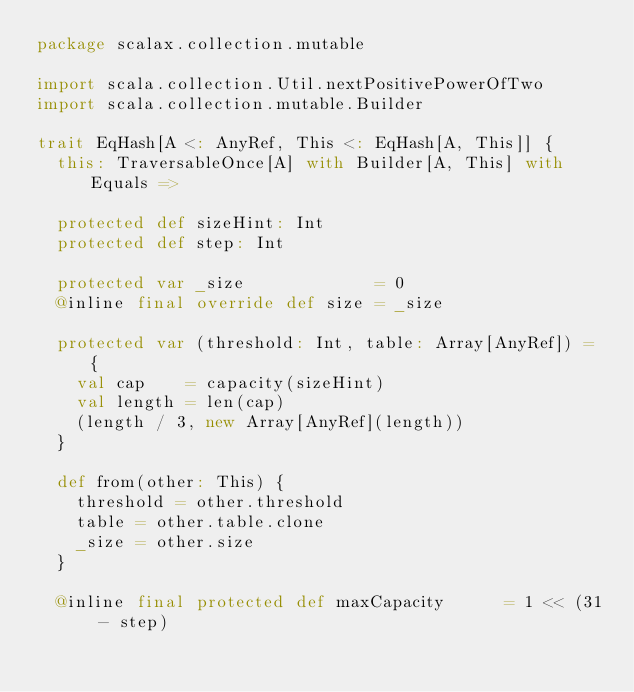<code> <loc_0><loc_0><loc_500><loc_500><_Scala_>package scalax.collection.mutable

import scala.collection.Util.nextPositivePowerOfTwo
import scala.collection.mutable.Builder

trait EqHash[A <: AnyRef, This <: EqHash[A, This]] {
  this: TraversableOnce[A] with Builder[A, This] with Equals =>

  protected def sizeHint: Int
  protected def step: Int

  protected var _size             = 0
  @inline final override def size = _size

  protected var (threshold: Int, table: Array[AnyRef]) = {
    val cap    = capacity(sizeHint)
    val length = len(cap)
    (length / 3, new Array[AnyRef](length))
  }

  def from(other: This) {
    threshold = other.threshold
    table = other.table.clone
    _size = other.size
  }

  @inline final protected def maxCapacity      = 1 << (31 - step)</code> 